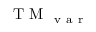Convert formula to latex. <formula><loc_0><loc_0><loc_500><loc_500>T M _ { v a r }</formula> 